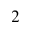<formula> <loc_0><loc_0><loc_500><loc_500>^ { 2 }</formula> 